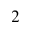<formula> <loc_0><loc_0><loc_500><loc_500>^ { 2 }</formula> 